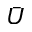Convert formula to latex. <formula><loc_0><loc_0><loc_500><loc_500>\bar { U }</formula> 